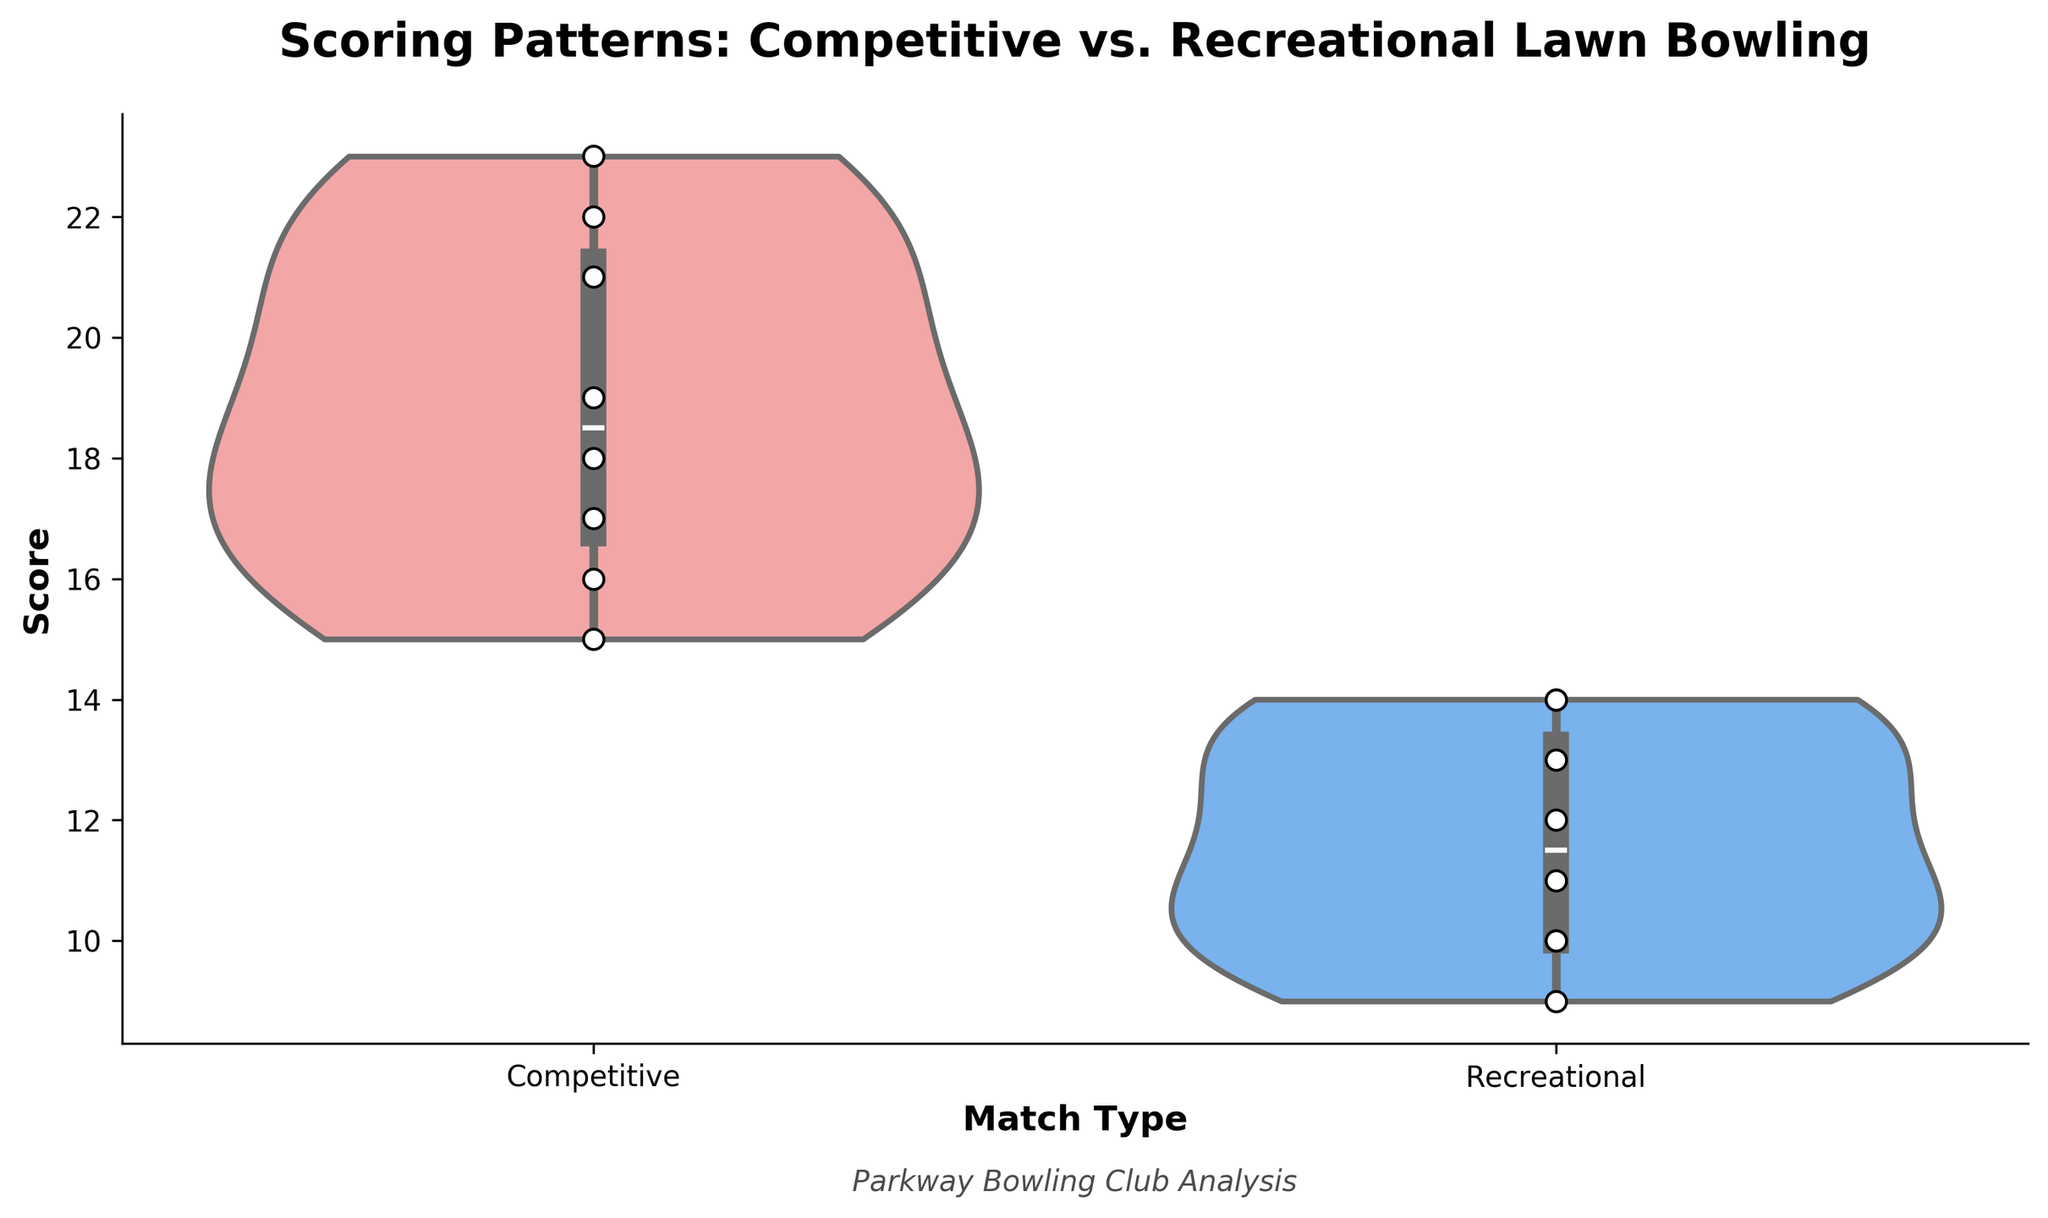What's the title of the figure? The title is typically displayed at the top of the chart, providing a brief summary of what the chart is about. In this case, the title is "Scoring Patterns: Competitive vs. Recreational Lawn Bowling".
Answer: Scoring Patterns: Competitive vs. Recreational Lawn Bowling What colors are used to represent Competitive and Recreational matches? The color palette used in the chart designates Competitive matches in light red and Recreational matches in light blue. This can be inferred from the two different shades seen around each violin plot.
Answer: Light red and light blue How many data points are there in the Competitive matches? To find the number of data points, count the individual scatter points on the violin plot for Competitive matches. The figure shows 8 such scatter points in the section labeled "Competitive".
Answer: 8 What is the range of scores for Recreational matches? The range can be determined by looking at the highest and lowest points in the "Recreational" violin plot. The highest score appears to be 14, and the lowest score appears to be 9. Thus, the range is 14 - 9.
Answer: 5 Which match type shows a higher median score? In a violin plot with box plot elements, the median is represented by a line inside the box. For Competitive matches, the median line is higher in position compared to Recreational matches. Thus, Competitive matches show a higher median score.
Answer: Competitive matches What is the interquartile range (IQR) for Competitive matches? The IQR is calculated by subtracting the first quartile (Q1) from the third quartile (Q3). In the violin plot, the box represents these quartiles. From the Competitive matches section, visually estimate Q1 around 16 and Q3 around 22. Thus, IQR is 22 - 16.
Answer: 6 What is the maximum score observed in the Competitive matches? The maximum score can be identified by the highest point on the violin plot for Competitive matches. This highest scatter point appears to be at 23.
Answer: 23 Between Competitive and Recreational matches, which has a wider distribution of scores? The width of the violin plot indicates the distribution. Comparing the two plots, the Competitive matches plot spans a wider range, indicating a wider distribution.
Answer: Competitive matches How do the scores of Emily Clarke (Competitive) and Brian Martinez (Recreational) compare? Emily Clarke's score is 19, and Brian Martinez's score is 14. Comparing the two, Emily Clarke's score is higher.
Answer: Emily Clarke's score is higher than Brian Martinez's What is the approximate average score of Recreational matches? Calculate the average by summing the scores of Recreational matches and dividing by the number of data points: (10 + 14 + 12 + 11 + 13 + 9 + 10 + 14) / 8 = 11.625.
Answer: 11.625 